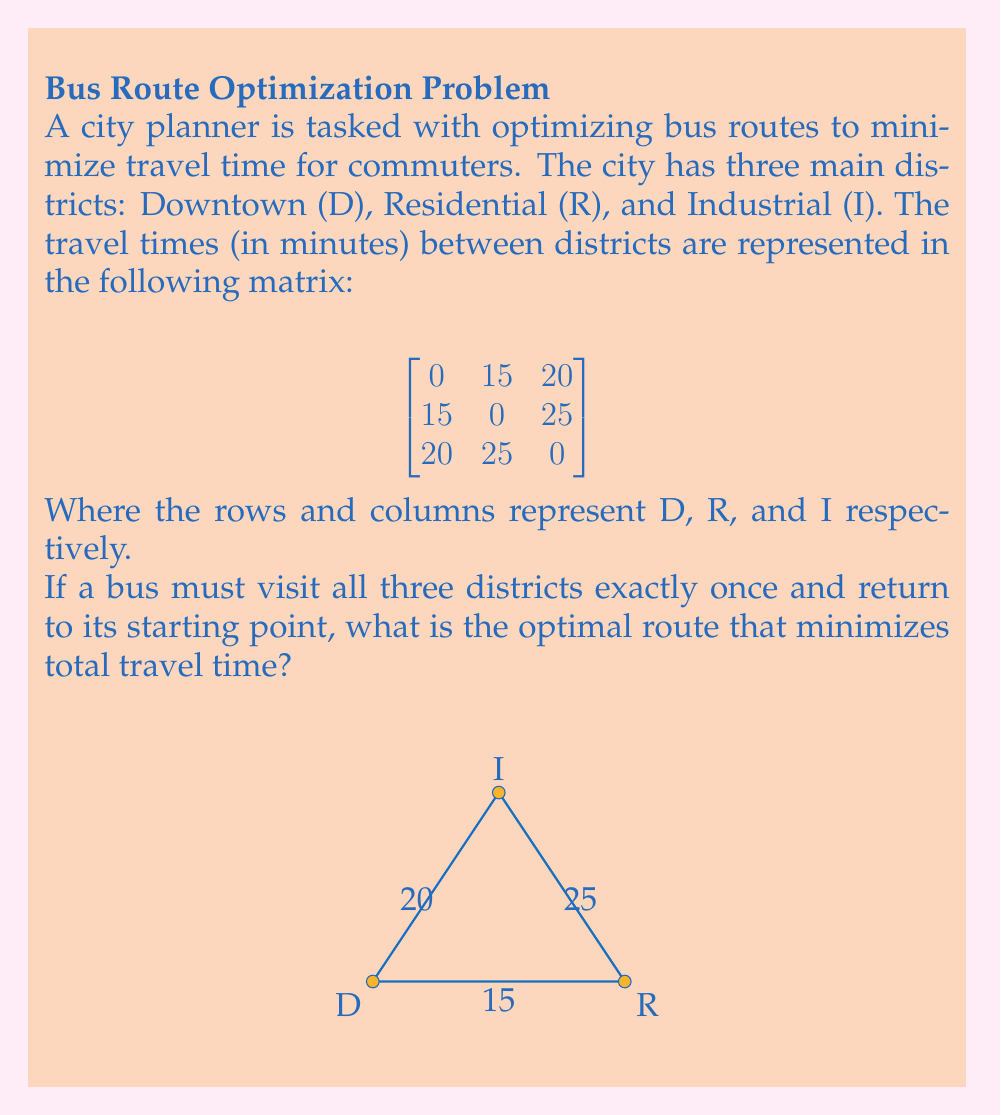Can you answer this question? To solve this problem, we can use a simple application of linear programming techniques, specifically the Traveling Salesman Problem (TSP) approach.

Step 1: Identify all possible routes
There are 3! = 6 possible routes:
1. D → R → I → D
2. D → I → R → D
3. R → D → I → R
4. R → I → D → R
5. I → D → R → I
6. I → R → D → I

Step 2: Calculate the total travel time for each route
1. D → R → I → D: 15 + 25 + 20 = 60 minutes
2. D → I → R → D: 20 + 25 + 15 = 60 minutes
3. R → D → I → R: 15 + 20 + 25 = 60 minutes
4. R → I → D → R: 25 + 20 + 15 = 60 minutes
5. I → D → R → I: 20 + 15 + 25 = 60 minutes
6. I → R → D → I: 25 + 15 + 20 = 60 minutes

Step 3: Identify the optimal route(s)
In this case, all routes have the same total travel time of 60 minutes. This is because the matrix is symmetric, meaning the travel time from A to B is the same as from B to A for all pairs of districts.

Step 4: Consider practical implications
Since all routes have the same total travel time, the city planner can choose any route based on other factors such as traffic patterns, passenger preferences, or bus depot locations. For simplicity, we can choose the first route: D → R → I → D.
Answer: Any route; all have 60 minutes total travel time. E.g., D → R → I → D. 